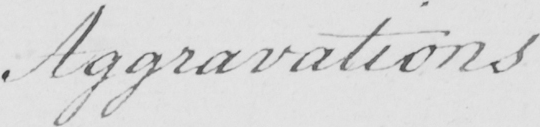What does this handwritten line say? Aggravations 